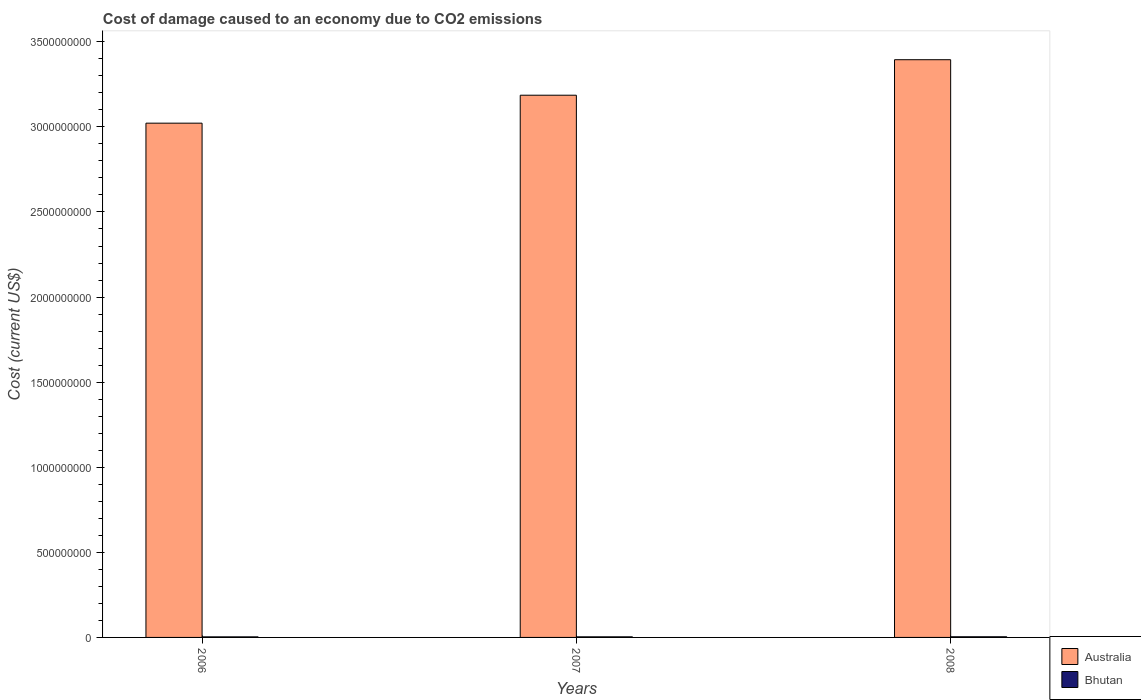How many groups of bars are there?
Give a very brief answer. 3. How many bars are there on the 3rd tick from the left?
Offer a very short reply. 2. What is the label of the 3rd group of bars from the left?
Offer a very short reply. 2008. In how many cases, is the number of bars for a given year not equal to the number of legend labels?
Give a very brief answer. 0. What is the cost of damage caused due to CO2 emissisons in Bhutan in 2008?
Give a very brief answer. 3.81e+06. Across all years, what is the maximum cost of damage caused due to CO2 emissisons in Bhutan?
Provide a short and direct response. 3.81e+06. Across all years, what is the minimum cost of damage caused due to CO2 emissisons in Bhutan?
Make the answer very short. 3.31e+06. In which year was the cost of damage caused due to CO2 emissisons in Bhutan minimum?
Give a very brief answer. 2006. What is the total cost of damage caused due to CO2 emissisons in Australia in the graph?
Make the answer very short. 9.60e+09. What is the difference between the cost of damage caused due to CO2 emissisons in Bhutan in 2006 and that in 2007?
Keep it short and to the point. -1.24e+05. What is the difference between the cost of damage caused due to CO2 emissisons in Bhutan in 2008 and the cost of damage caused due to CO2 emissisons in Australia in 2007?
Provide a succinct answer. -3.18e+09. What is the average cost of damage caused due to CO2 emissisons in Bhutan per year?
Provide a succinct answer. 3.52e+06. In the year 2008, what is the difference between the cost of damage caused due to CO2 emissisons in Australia and cost of damage caused due to CO2 emissisons in Bhutan?
Offer a very short reply. 3.39e+09. In how many years, is the cost of damage caused due to CO2 emissisons in Bhutan greater than 1700000000 US$?
Your answer should be compact. 0. What is the ratio of the cost of damage caused due to CO2 emissisons in Bhutan in 2006 to that in 2008?
Ensure brevity in your answer.  0.87. Is the cost of damage caused due to CO2 emissisons in Australia in 2006 less than that in 2007?
Offer a very short reply. Yes. What is the difference between the highest and the second highest cost of damage caused due to CO2 emissisons in Australia?
Make the answer very short. 2.09e+08. What is the difference between the highest and the lowest cost of damage caused due to CO2 emissisons in Australia?
Offer a very short reply. 3.73e+08. What does the 2nd bar from the left in 2006 represents?
Your answer should be very brief. Bhutan. What does the 1st bar from the right in 2008 represents?
Your answer should be compact. Bhutan. Does the graph contain grids?
Your answer should be very brief. No. How are the legend labels stacked?
Your answer should be compact. Vertical. What is the title of the graph?
Ensure brevity in your answer.  Cost of damage caused to an economy due to CO2 emissions. Does "Luxembourg" appear as one of the legend labels in the graph?
Your response must be concise. No. What is the label or title of the Y-axis?
Offer a terse response. Cost (current US$). What is the Cost (current US$) of Australia in 2006?
Your answer should be compact. 3.02e+09. What is the Cost (current US$) of Bhutan in 2006?
Your response must be concise. 3.31e+06. What is the Cost (current US$) of Australia in 2007?
Offer a terse response. 3.19e+09. What is the Cost (current US$) of Bhutan in 2007?
Keep it short and to the point. 3.44e+06. What is the Cost (current US$) in Australia in 2008?
Give a very brief answer. 3.39e+09. What is the Cost (current US$) of Bhutan in 2008?
Offer a terse response. 3.81e+06. Across all years, what is the maximum Cost (current US$) in Australia?
Provide a succinct answer. 3.39e+09. Across all years, what is the maximum Cost (current US$) of Bhutan?
Offer a very short reply. 3.81e+06. Across all years, what is the minimum Cost (current US$) in Australia?
Offer a terse response. 3.02e+09. Across all years, what is the minimum Cost (current US$) of Bhutan?
Ensure brevity in your answer.  3.31e+06. What is the total Cost (current US$) in Australia in the graph?
Provide a succinct answer. 9.60e+09. What is the total Cost (current US$) in Bhutan in the graph?
Give a very brief answer. 1.06e+07. What is the difference between the Cost (current US$) of Australia in 2006 and that in 2007?
Ensure brevity in your answer.  -1.64e+08. What is the difference between the Cost (current US$) of Bhutan in 2006 and that in 2007?
Offer a very short reply. -1.24e+05. What is the difference between the Cost (current US$) of Australia in 2006 and that in 2008?
Provide a succinct answer. -3.73e+08. What is the difference between the Cost (current US$) in Bhutan in 2006 and that in 2008?
Your answer should be very brief. -4.93e+05. What is the difference between the Cost (current US$) in Australia in 2007 and that in 2008?
Make the answer very short. -2.09e+08. What is the difference between the Cost (current US$) in Bhutan in 2007 and that in 2008?
Your answer should be compact. -3.69e+05. What is the difference between the Cost (current US$) in Australia in 2006 and the Cost (current US$) in Bhutan in 2007?
Keep it short and to the point. 3.02e+09. What is the difference between the Cost (current US$) of Australia in 2006 and the Cost (current US$) of Bhutan in 2008?
Make the answer very short. 3.02e+09. What is the difference between the Cost (current US$) in Australia in 2007 and the Cost (current US$) in Bhutan in 2008?
Provide a succinct answer. 3.18e+09. What is the average Cost (current US$) of Australia per year?
Offer a terse response. 3.20e+09. What is the average Cost (current US$) in Bhutan per year?
Offer a terse response. 3.52e+06. In the year 2006, what is the difference between the Cost (current US$) in Australia and Cost (current US$) in Bhutan?
Your response must be concise. 3.02e+09. In the year 2007, what is the difference between the Cost (current US$) of Australia and Cost (current US$) of Bhutan?
Ensure brevity in your answer.  3.18e+09. In the year 2008, what is the difference between the Cost (current US$) of Australia and Cost (current US$) of Bhutan?
Keep it short and to the point. 3.39e+09. What is the ratio of the Cost (current US$) in Australia in 2006 to that in 2007?
Provide a short and direct response. 0.95. What is the ratio of the Cost (current US$) of Bhutan in 2006 to that in 2007?
Your answer should be compact. 0.96. What is the ratio of the Cost (current US$) in Australia in 2006 to that in 2008?
Offer a very short reply. 0.89. What is the ratio of the Cost (current US$) in Bhutan in 2006 to that in 2008?
Give a very brief answer. 0.87. What is the ratio of the Cost (current US$) of Australia in 2007 to that in 2008?
Provide a short and direct response. 0.94. What is the ratio of the Cost (current US$) in Bhutan in 2007 to that in 2008?
Your answer should be very brief. 0.9. What is the difference between the highest and the second highest Cost (current US$) of Australia?
Keep it short and to the point. 2.09e+08. What is the difference between the highest and the second highest Cost (current US$) of Bhutan?
Provide a short and direct response. 3.69e+05. What is the difference between the highest and the lowest Cost (current US$) in Australia?
Offer a very short reply. 3.73e+08. What is the difference between the highest and the lowest Cost (current US$) in Bhutan?
Your answer should be compact. 4.93e+05. 